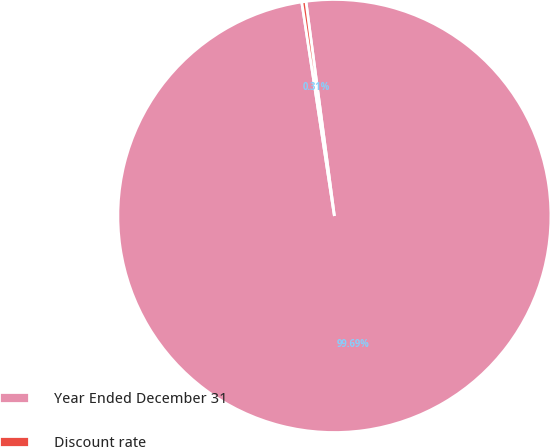Convert chart. <chart><loc_0><loc_0><loc_500><loc_500><pie_chart><fcel>Year Ended December 31<fcel>Discount rate<nl><fcel>99.69%<fcel>0.31%<nl></chart> 